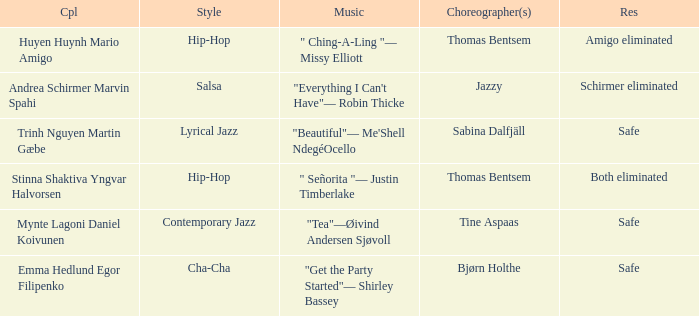What twosome had a positive outcome and showcased a lyrical jazz flair? Trinh Nguyen Martin Gæbe. 